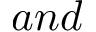Convert formula to latex. <formula><loc_0><loc_0><loc_500><loc_500>a n d</formula> 